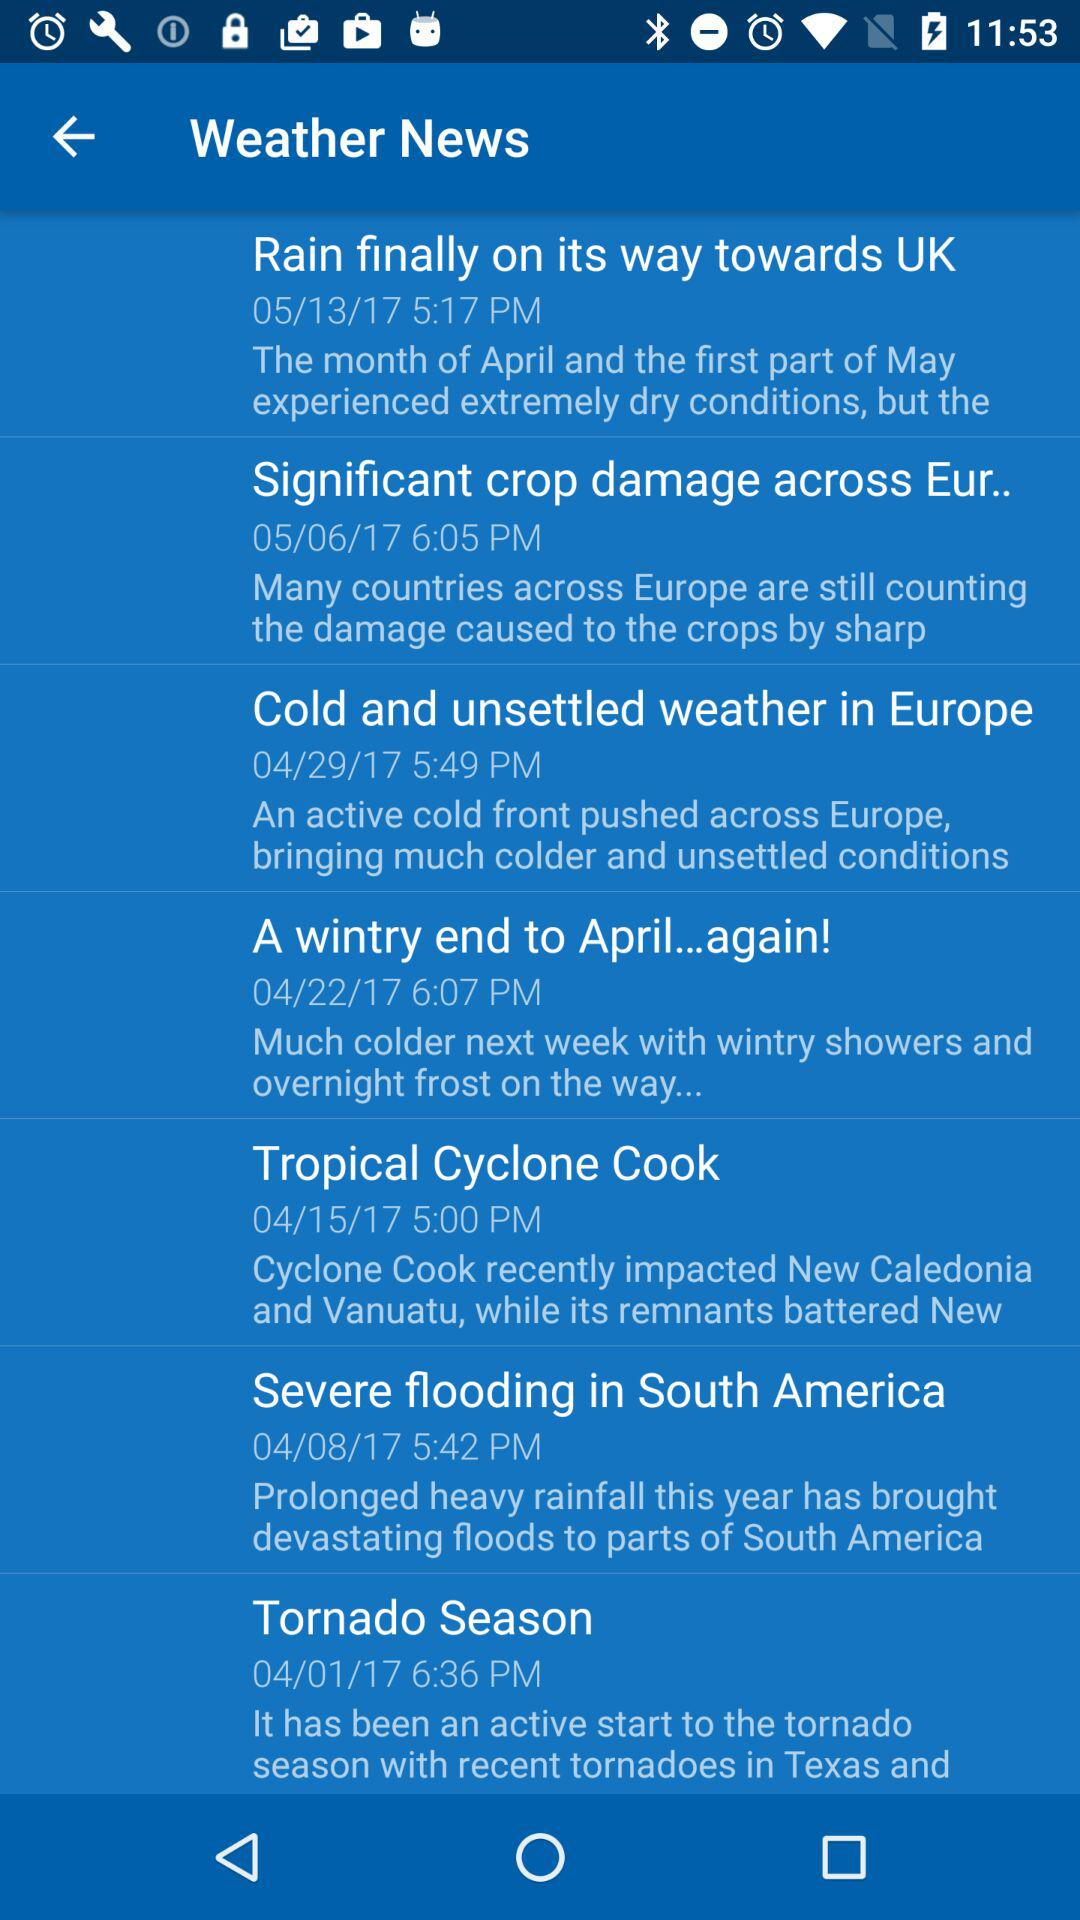At what time was the "Tornado Season" news published? The news was published at 6:36 PM. 